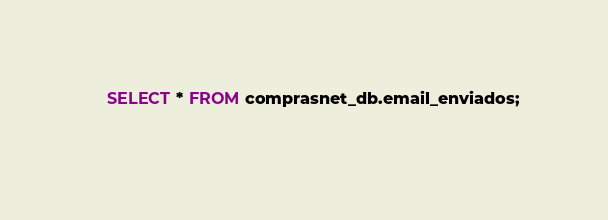<code> <loc_0><loc_0><loc_500><loc_500><_SQL_>	SELECT * FROM comprasnet_db.email_enviados;
    </code> 